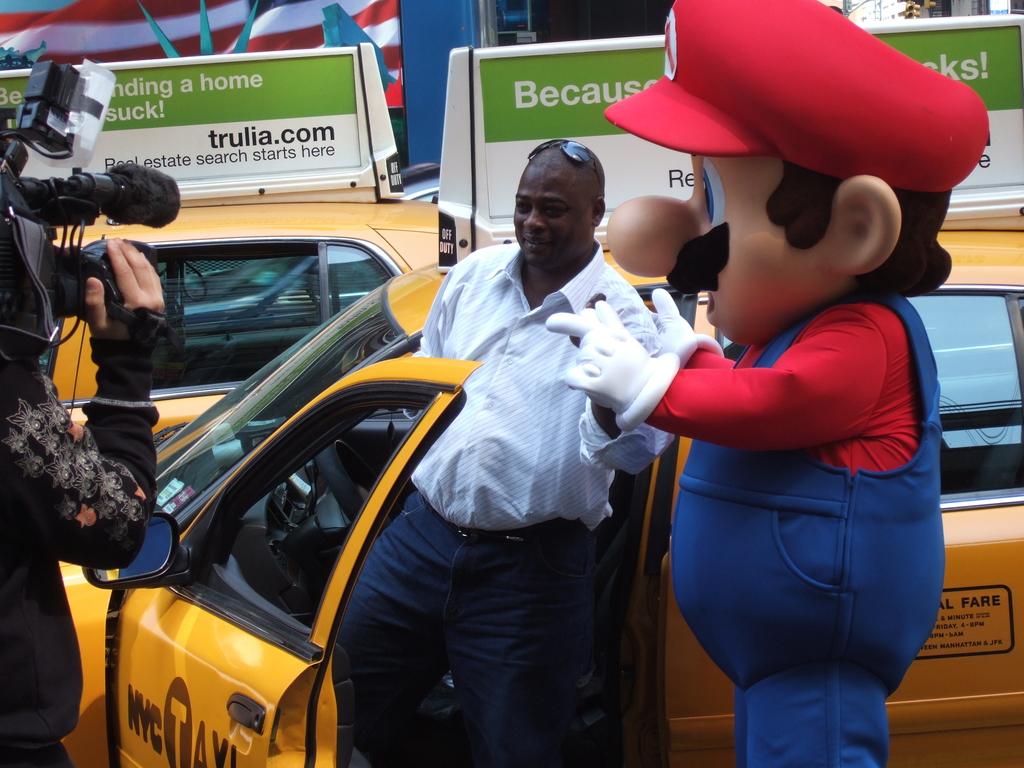What city does the taxi belong to?
Keep it short and to the point. Nyc. What website should you visit to start your real estate search?
Offer a very short reply. Trulia.com. 